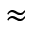Convert formula to latex. <formula><loc_0><loc_0><loc_500><loc_500>\approx</formula> 